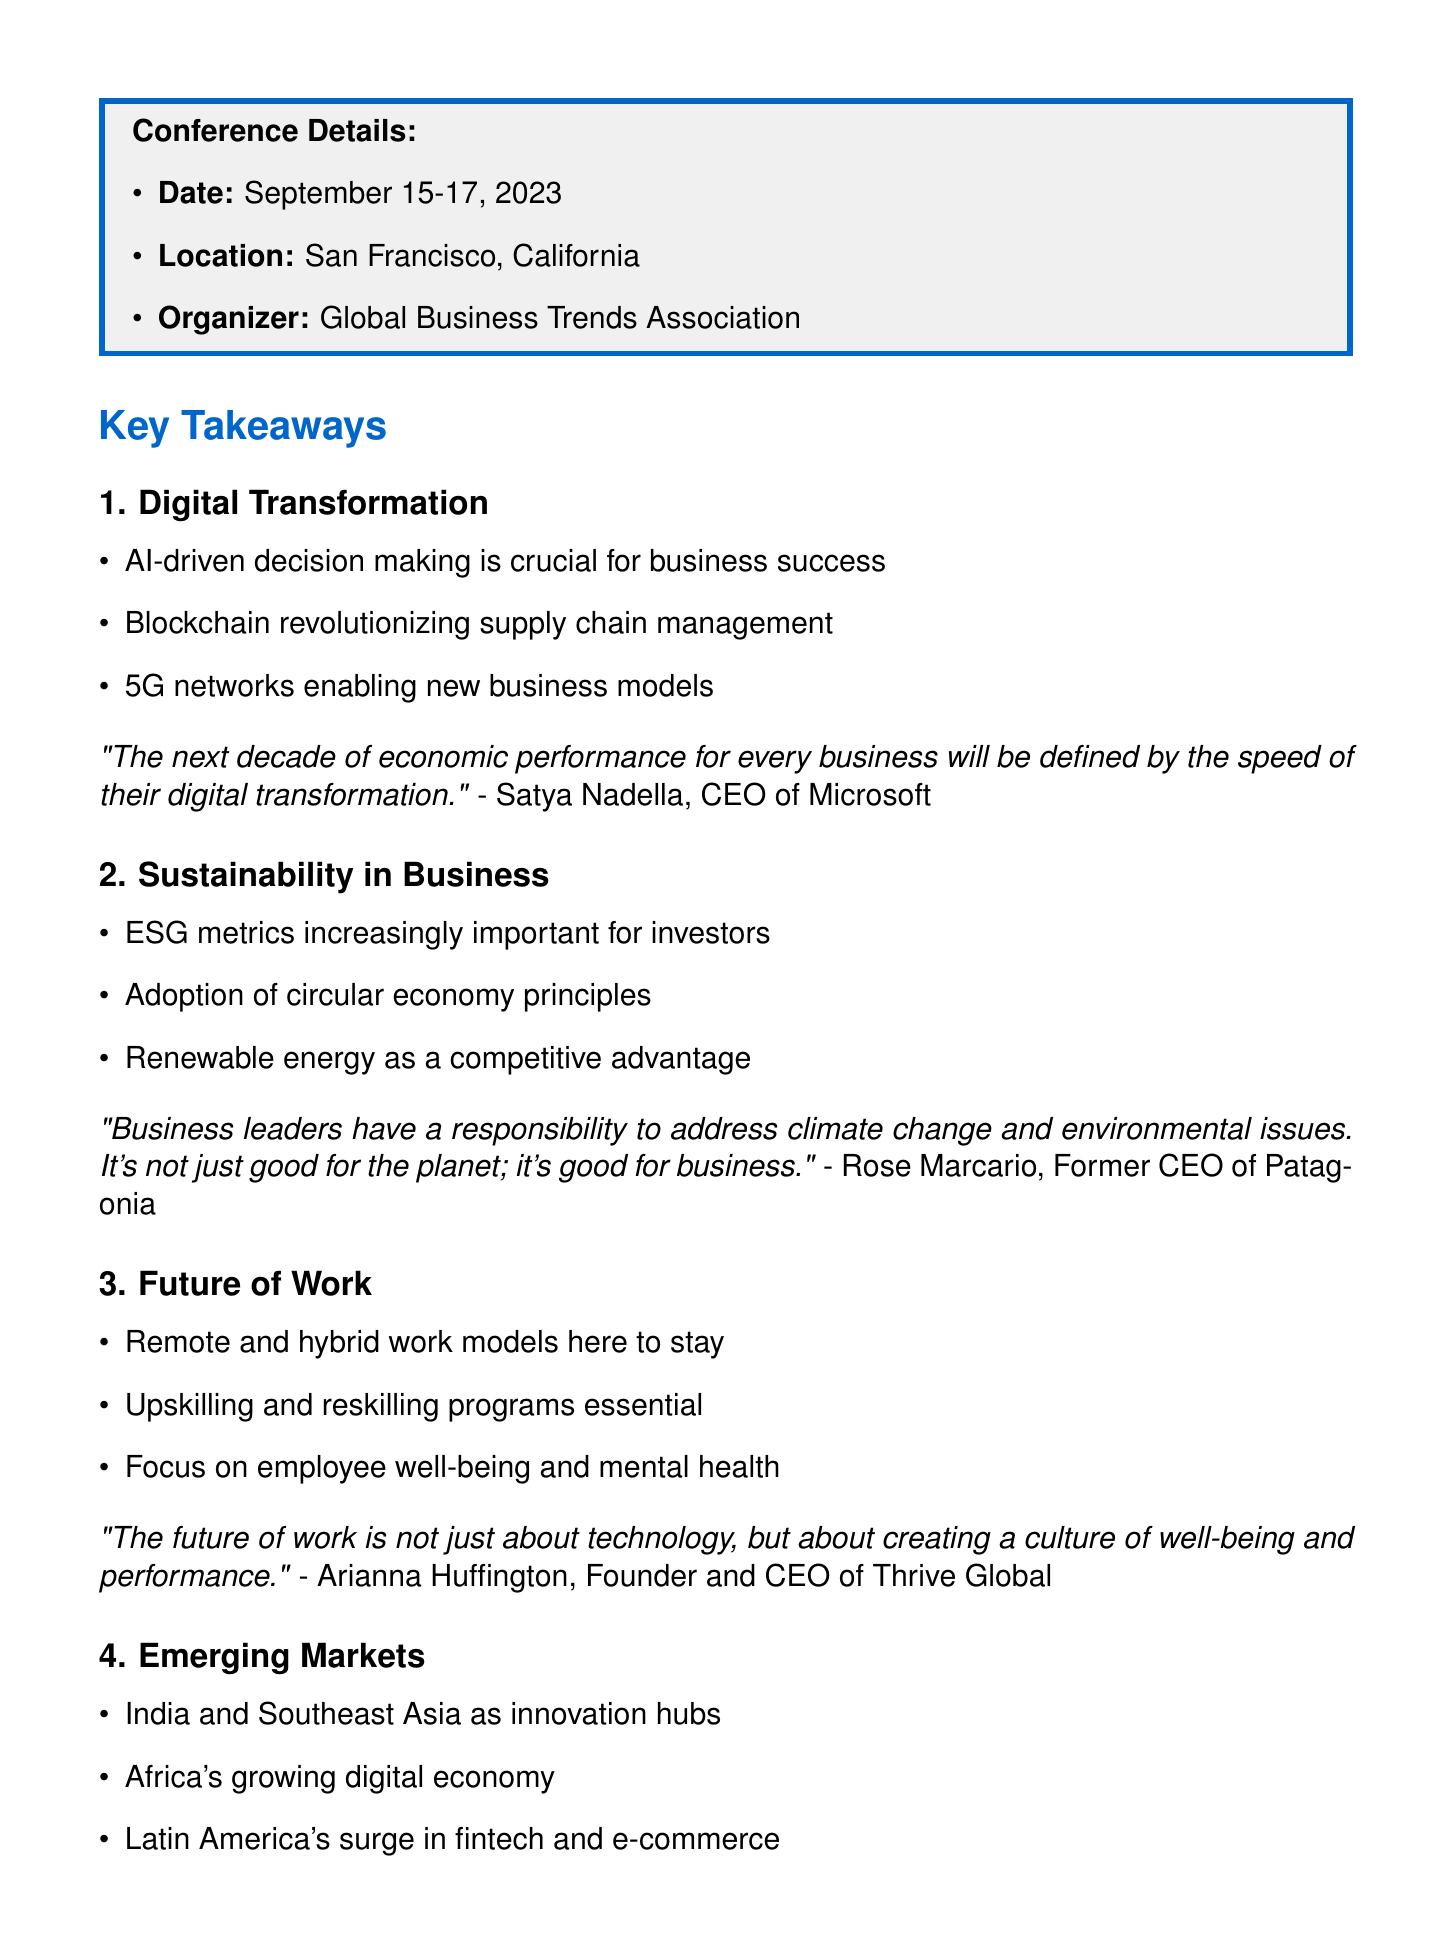What is the name of the conference? The name of the conference is the FutureBiz 2023.
Answer: FutureBiz 2023 Who was the notable speaker for Digital Transformation? The notable speaker for Digital Transformation is Satya Nadella.
Answer: Satya Nadella What technology is revolutionizing supply chain management? The technology that is revolutionizing supply chain management is Blockchain.
Answer: Blockchain What is an emerging market mentioned in the key takeaways? An emerging market mentioned is India.
Answer: India Who emphasized the importance of ESG metrics? Rose Marcario emphasized the importance of ESG metrics.
Answer: Rose Marcario What is one networking opportunity mentioned in the document? One networking opportunity mentioned is the CEO Mentorship Program.
Answer: CEO Mentorship Program What is one recommended follow-up action? One recommended follow-up action is to review presentation slides on the conference website.
Answer: Review presentation slides on the conference website What date did the conference take place? The conference took place from September 15-17, 2023.
Answer: September 15-17, 2023 What is the focus of the theme "Future of Work"? The focus of the theme "Future of Work" includes employee well-being and mental health.
Answer: Employee well-being and mental health 